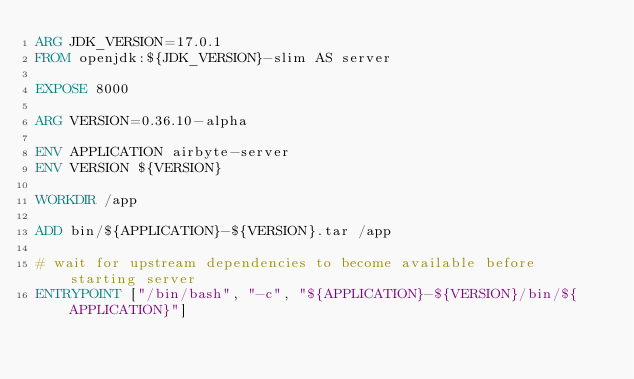<code> <loc_0><loc_0><loc_500><loc_500><_Dockerfile_>ARG JDK_VERSION=17.0.1
FROM openjdk:${JDK_VERSION}-slim AS server

EXPOSE 8000

ARG VERSION=0.36.10-alpha

ENV APPLICATION airbyte-server
ENV VERSION ${VERSION}

WORKDIR /app

ADD bin/${APPLICATION}-${VERSION}.tar /app

# wait for upstream dependencies to become available before starting server
ENTRYPOINT ["/bin/bash", "-c", "${APPLICATION}-${VERSION}/bin/${APPLICATION}"]
</code> 